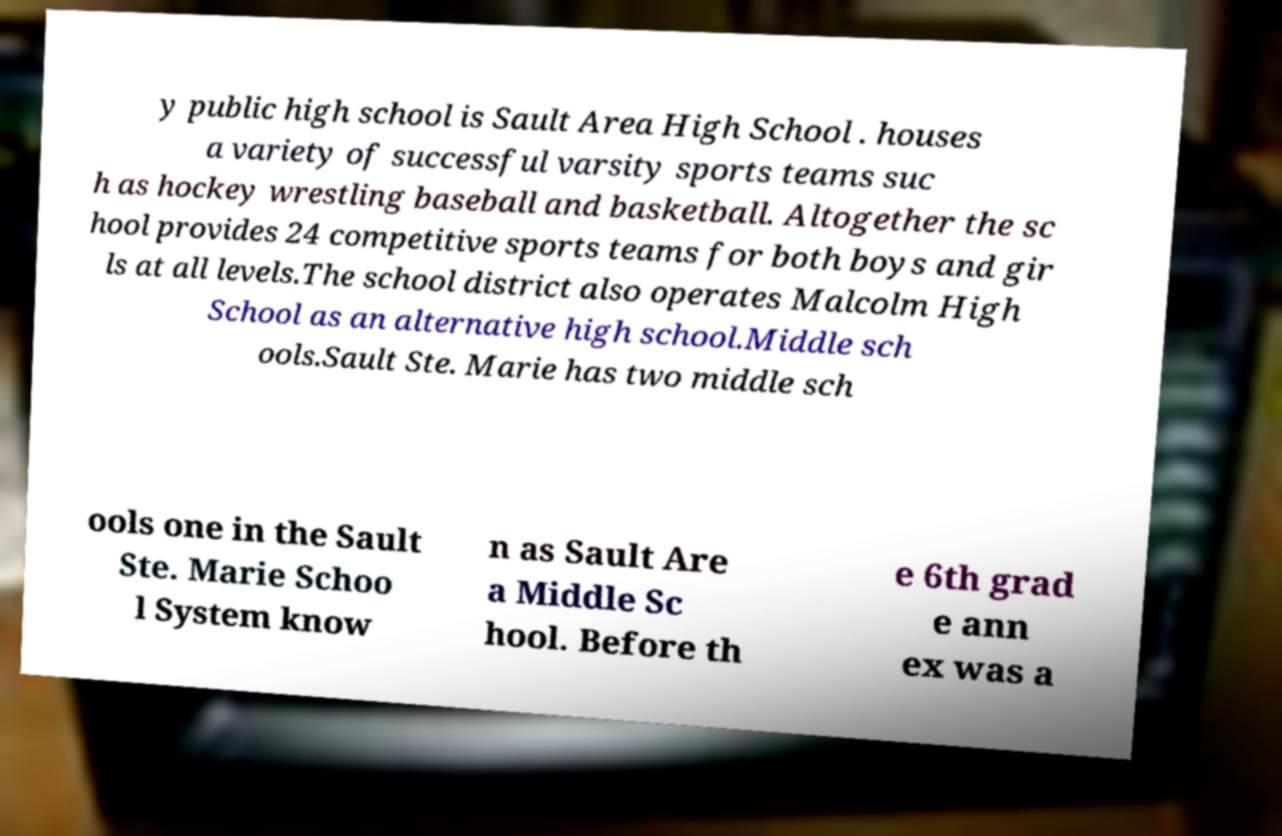What messages or text are displayed in this image? I need them in a readable, typed format. y public high school is Sault Area High School . houses a variety of successful varsity sports teams suc h as hockey wrestling baseball and basketball. Altogether the sc hool provides 24 competitive sports teams for both boys and gir ls at all levels.The school district also operates Malcolm High School as an alternative high school.Middle sch ools.Sault Ste. Marie has two middle sch ools one in the Sault Ste. Marie Schoo l System know n as Sault Are a Middle Sc hool. Before th e 6th grad e ann ex was a 